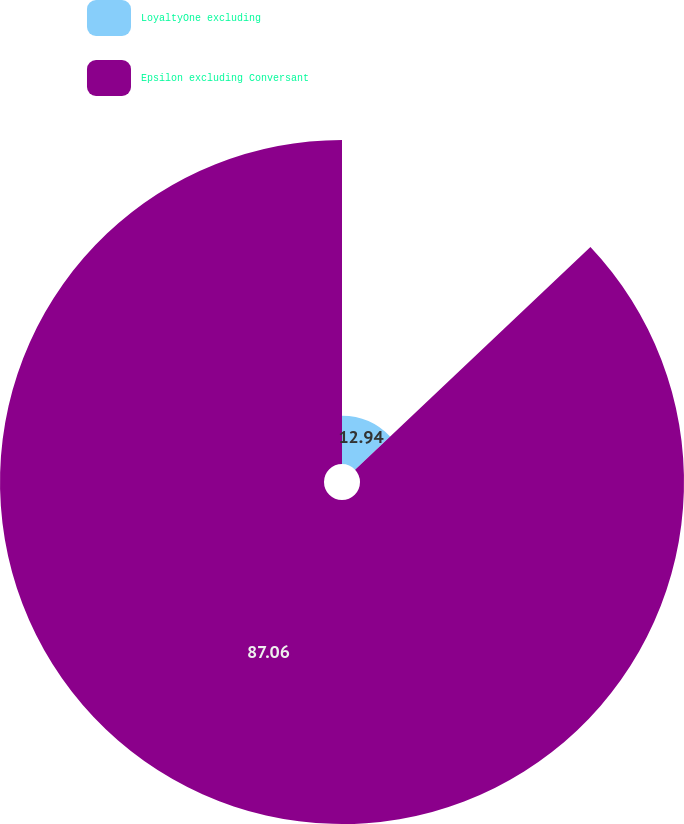Convert chart. <chart><loc_0><loc_0><loc_500><loc_500><pie_chart><fcel>LoyaltyOne excluding<fcel>Epsilon excluding Conversant<nl><fcel>12.94%<fcel>87.06%<nl></chart> 